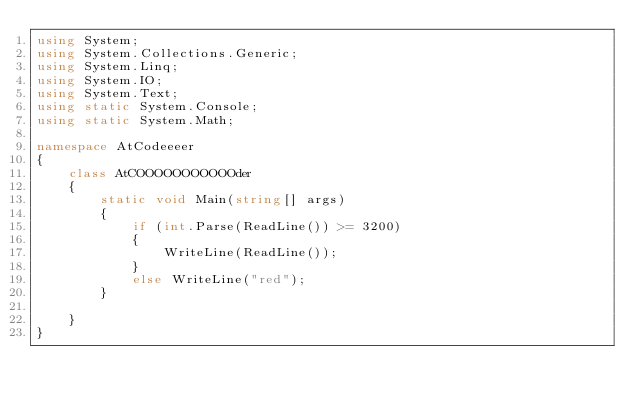Convert code to text. <code><loc_0><loc_0><loc_500><loc_500><_C#_>using System;
using System.Collections.Generic;
using System.Linq;
using System.IO;
using System.Text;
using static System.Console;
using static System.Math;

namespace AtCodeeeer
{
    class AtCOOOOOOOOOOOder
    {
        static void Main(string[] args)
        {
            if (int.Parse(ReadLine()) >= 3200)
            {
                WriteLine(ReadLine());
            }
            else WriteLine("red");
        }

    }
}

</code> 